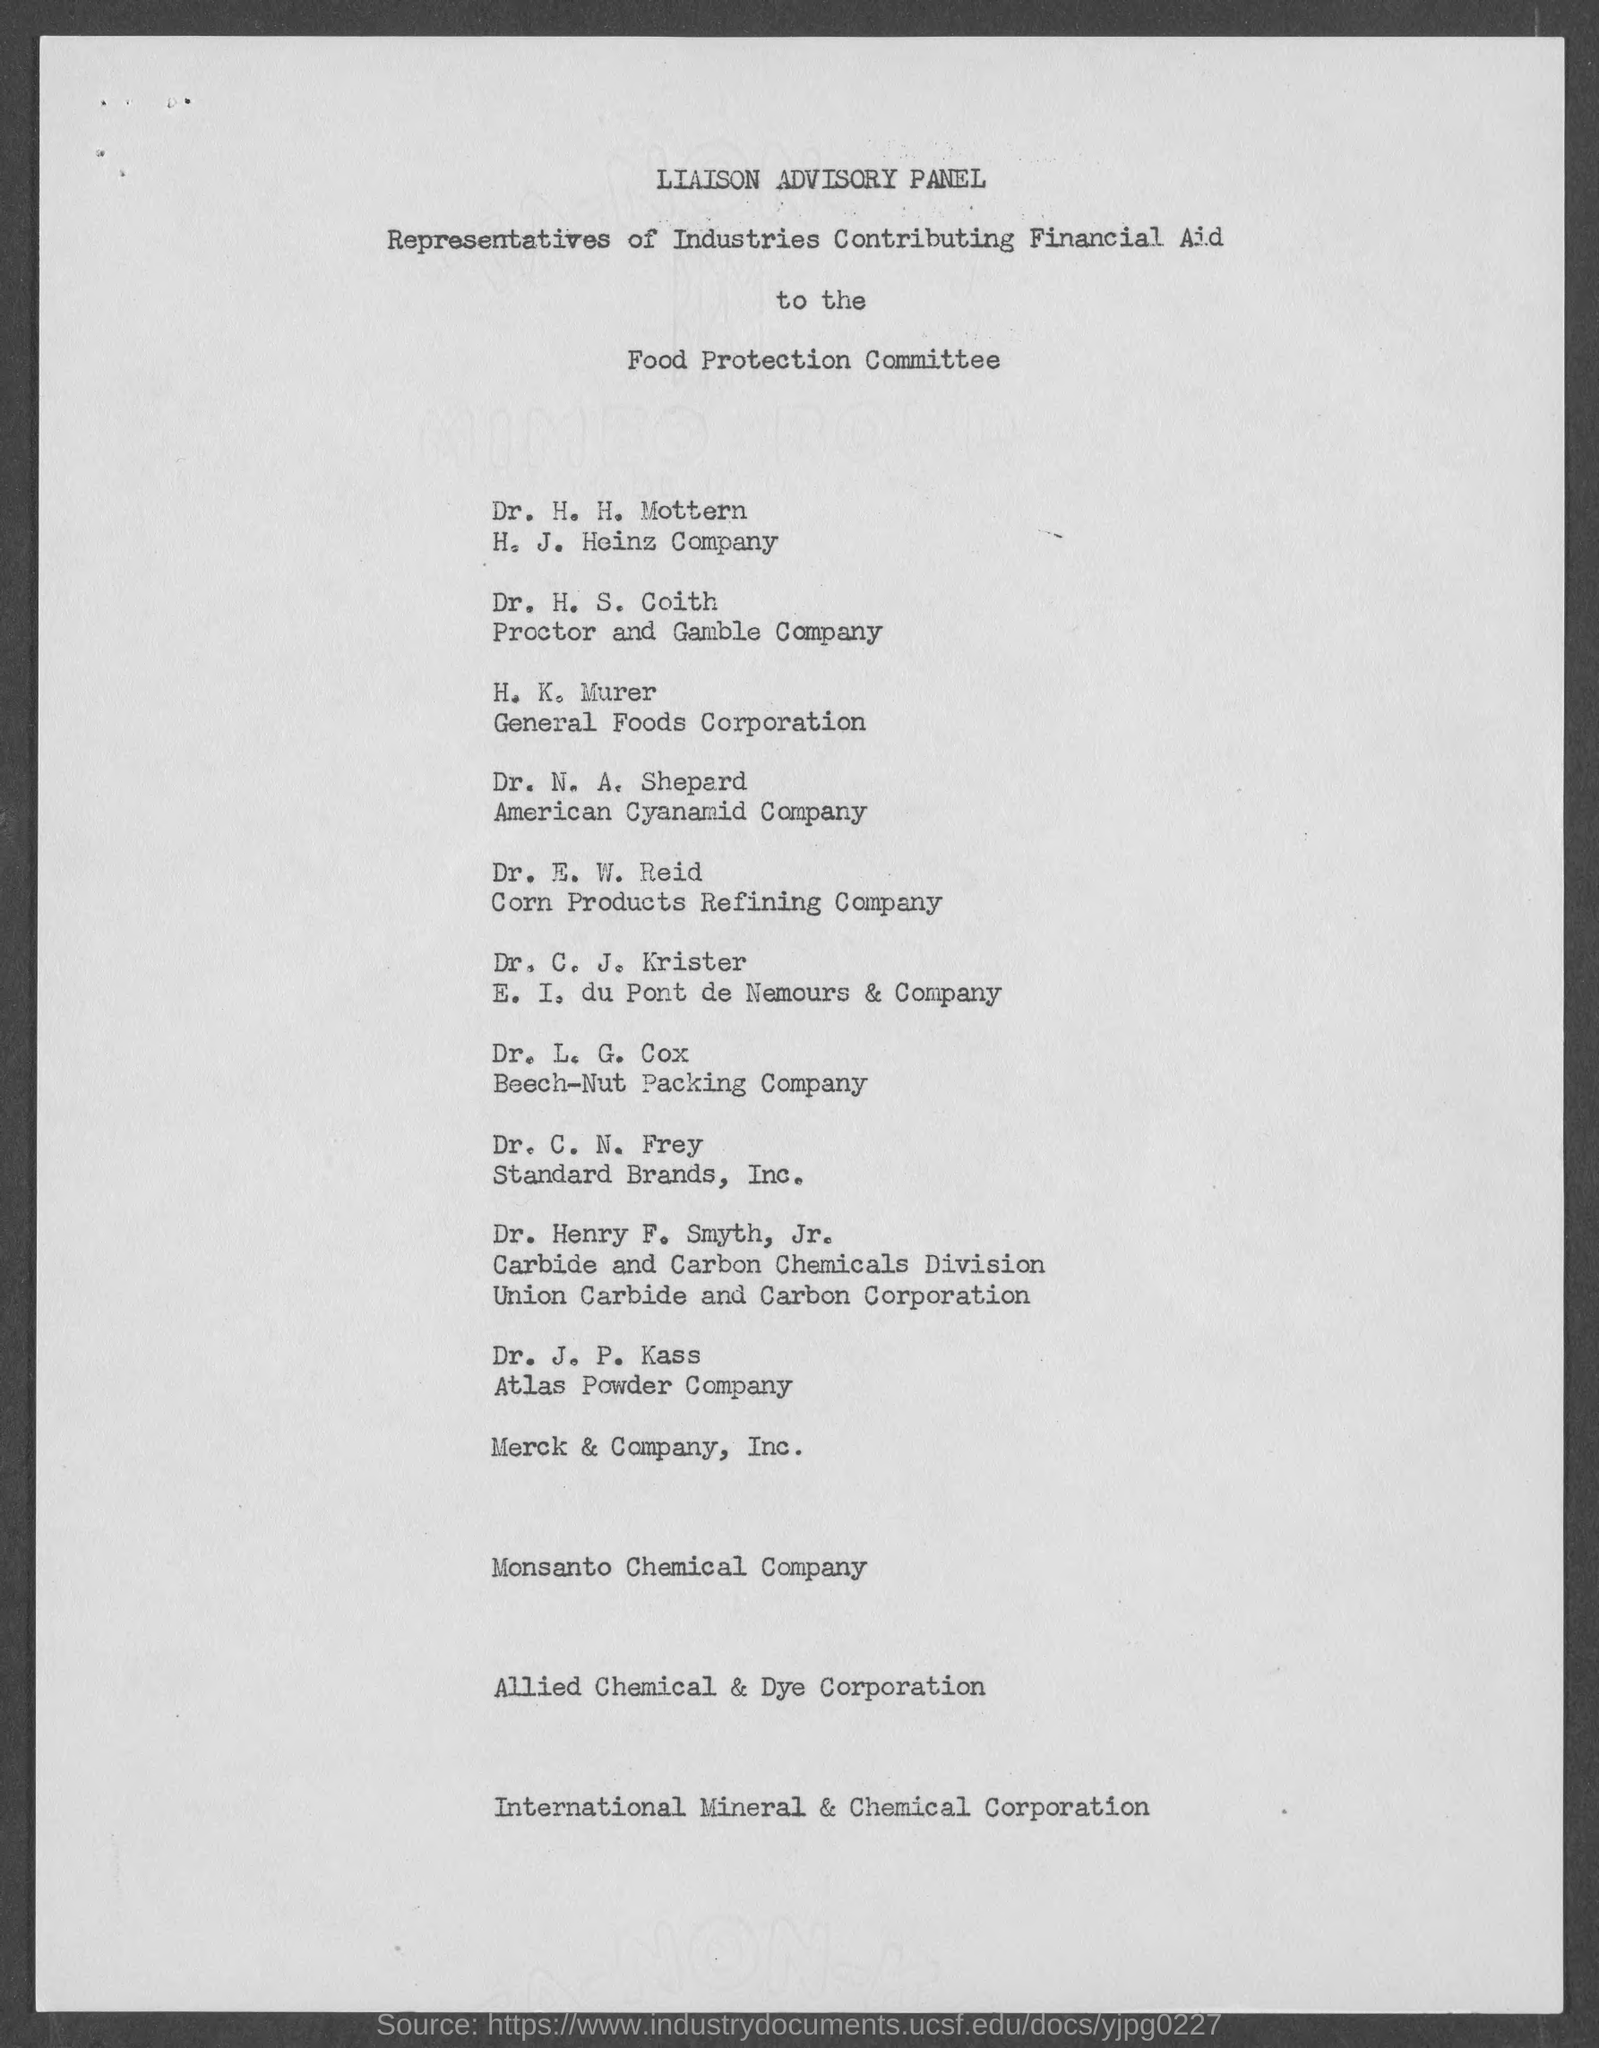Identify some key points in this picture. Dr. J.P. Kass is associated with the Atlas Powder Company. The second title in the document is 'Representatives of Industries Contributing Financial Aid...' C.N.Frey is affiliated with Standard Brands, Inc. N.A. Sheperd is an employee of the American Cyanamid Company. The document's first title is "Liaison Advisory Panel. 